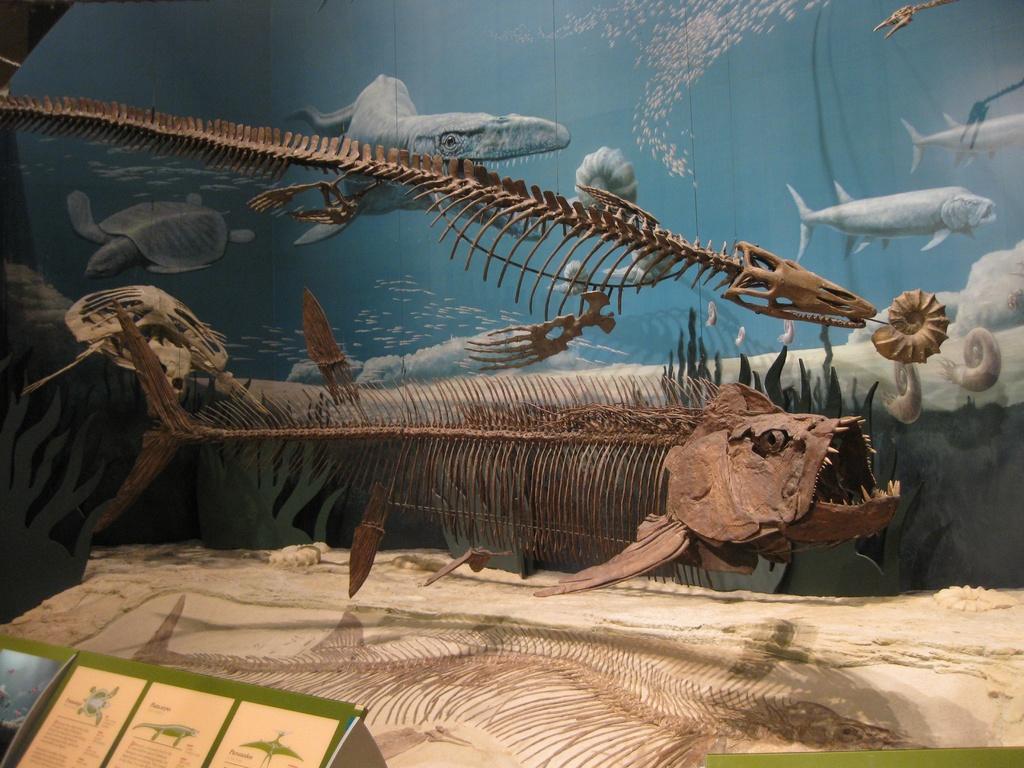How would you summarize this image in a sentence or two? In this image we can see the fish skeletons. In the background we can see the snails, tortoise and also fishes and water. We can also see the paper with text and images. 